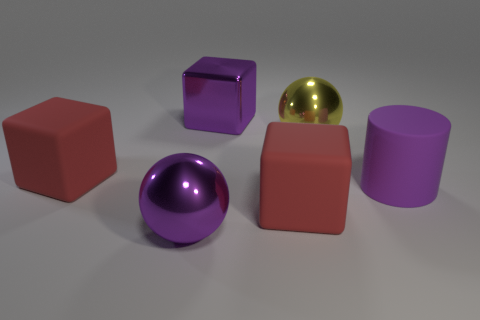Add 1 small red rubber cubes. How many objects exist? 7 Subtract all cylinders. How many objects are left? 5 Add 5 big purple metal cubes. How many big purple metal cubes are left? 6 Add 6 small cyan rubber cylinders. How many small cyan rubber cylinders exist? 6 Subtract 0 green cubes. How many objects are left? 6 Subtract all tiny blue metallic things. Subtract all big red objects. How many objects are left? 4 